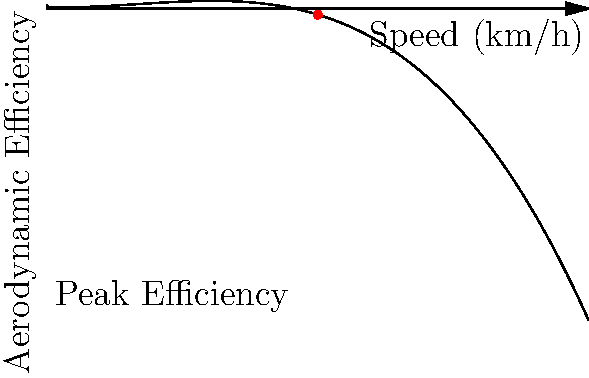Analyzing the aerodynamic efficiency curve of Simon Mann's car, at what speed (in km/h) does the car achieve its peak aerodynamic efficiency? To find the speed at which Simon Mann's car achieves peak aerodynamic efficiency, we need to analyze the given polynomial curve. The curve represents the relationship between the car's speed and its aerodynamic efficiency.

Steps to determine the peak efficiency:

1. The polynomial function for the curve is:
   $f(x) = -0.0005x^3 + 0.05x^2 - 0.5x + 10$
   where $x$ represents speed in km/h and $f(x)$ represents aerodynamic efficiency.

2. To find the maximum point of this function, we need to find where its derivative equals zero:
   $f'(x) = -0.0015x^2 + 0.1x - 0.5$

3. Set $f'(x) = 0$ and solve:
   $-0.0015x^2 + 0.1x - 0.5 = 0$

4. This is a quadratic equation. Using the quadratic formula or a calculator, we find that the solution is approximately $x = 100$.

5. The second derivative $f''(x) = -0.003x + 0.1$ is negative when $x = 100$, confirming this is a maximum point.

6. Therefore, the peak aerodynamic efficiency occurs at a speed of 100 km/h.

This speed is also visually represented by the red dot on the curve in the graph.
Answer: 100 km/h 